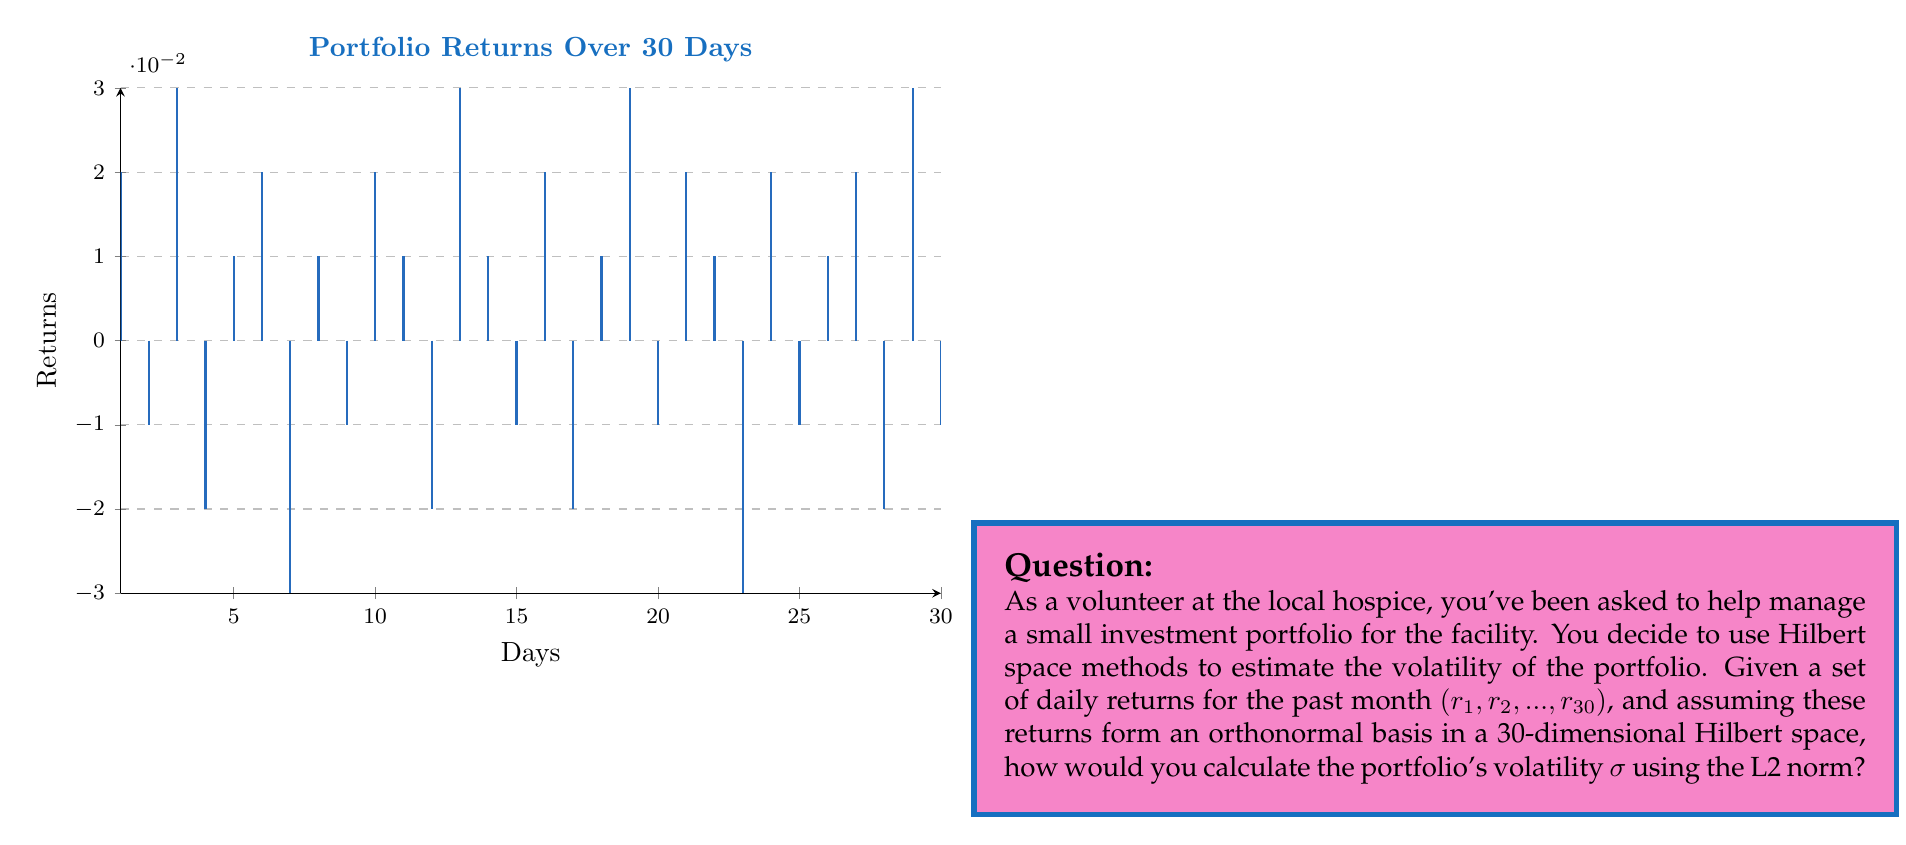Teach me how to tackle this problem. To estimate the volatility of the investment portfolio using Hilbert space methods, we'll follow these steps:

1) In a Hilbert space, the volatility $\sigma$ can be interpreted as the L2 norm of the returns vector.

2) Given that the returns $(r_1, r_2, ..., r_{30})$ form an orthonormal basis in a 30-dimensional Hilbert space, we can calculate the L2 norm as:

   $$\sigma = \sqrt{\sum_{i=1}^{30} |r_i|^2}$$

3) This formula is derived from the general definition of the L2 norm in a Hilbert space:

   $$\|x\|_2 = \sqrt{\langle x, x \rangle}$$

   where $\langle x, x \rangle$ is the inner product.

4) In our case, since the basis is orthonormal, the inner product simplifies to the sum of squared components.

5) To calculate this:
   - Square each daily return
   - Sum up all these squared values
   - Take the square root of the sum

6) The resulting value is the volatility $\sigma$, which represents the standard deviation of returns.

7) In practice, you would:
   $$\sigma = \sqrt{r_1^2 + r_2^2 + ... + r_{30}^2}$$

8) This method provides a quick way to estimate volatility without needing to calculate the mean return, making it computationally efficient for large datasets.

Note: In real-world applications, you might want to annualize this volatility by multiplying by $\sqrt{252}$ (assuming 252 trading days in a year), but this wasn't specified in the question.
Answer: $\sigma = \sqrt{\sum_{i=1}^{30} |r_i|^2}$ 